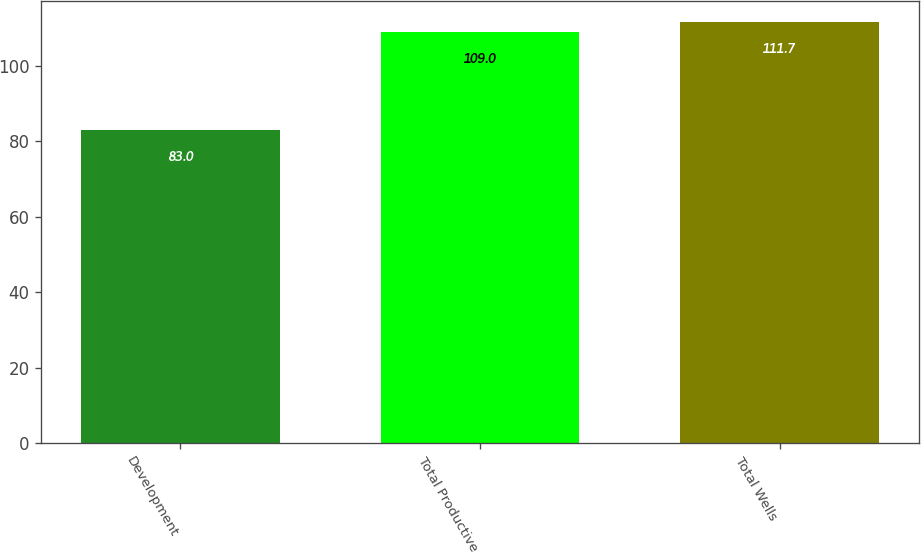<chart> <loc_0><loc_0><loc_500><loc_500><bar_chart><fcel>Development<fcel>Total Productive<fcel>Total Wells<nl><fcel>83<fcel>109<fcel>111.7<nl></chart> 